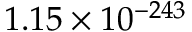Convert formula to latex. <formula><loc_0><loc_0><loc_500><loc_500>1 . 1 5 \times 1 0 ^ { - 2 4 3 }</formula> 